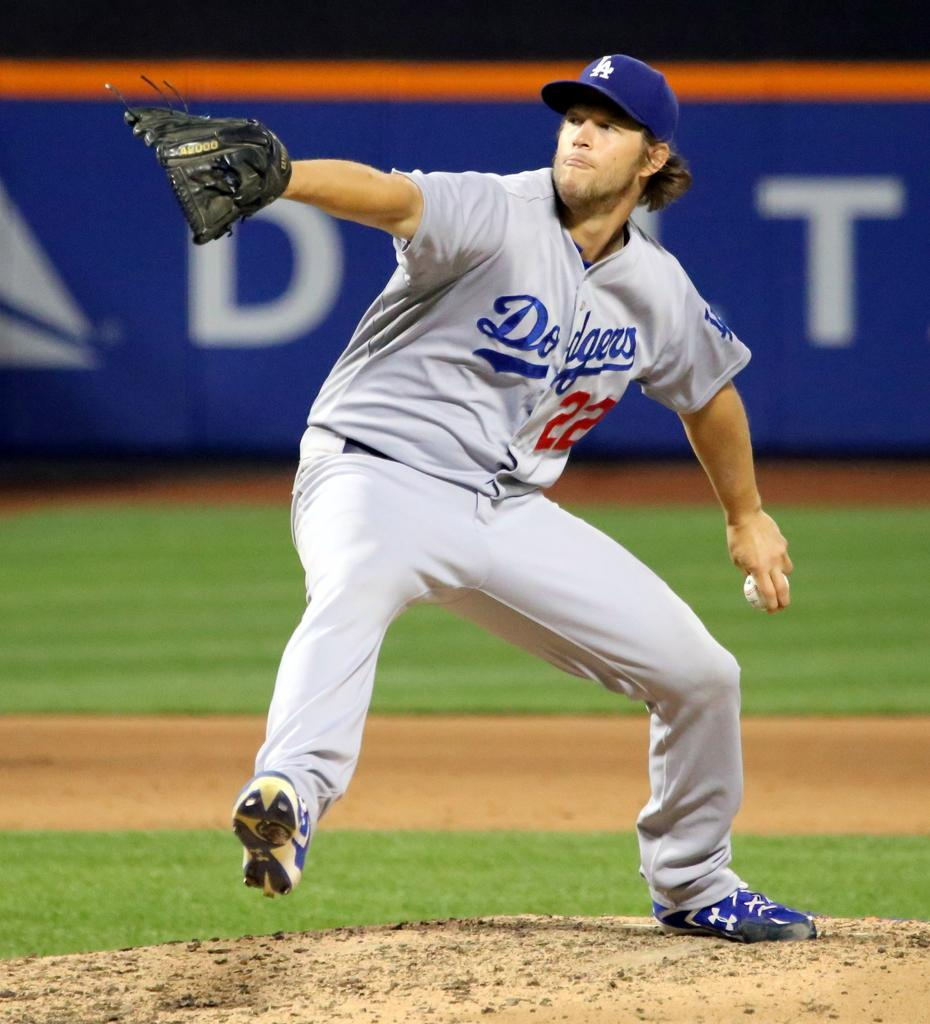<image>
Offer a succinct explanation of the picture presented. A dodgers baseball player wearing 22 prepares to throw the ball. 